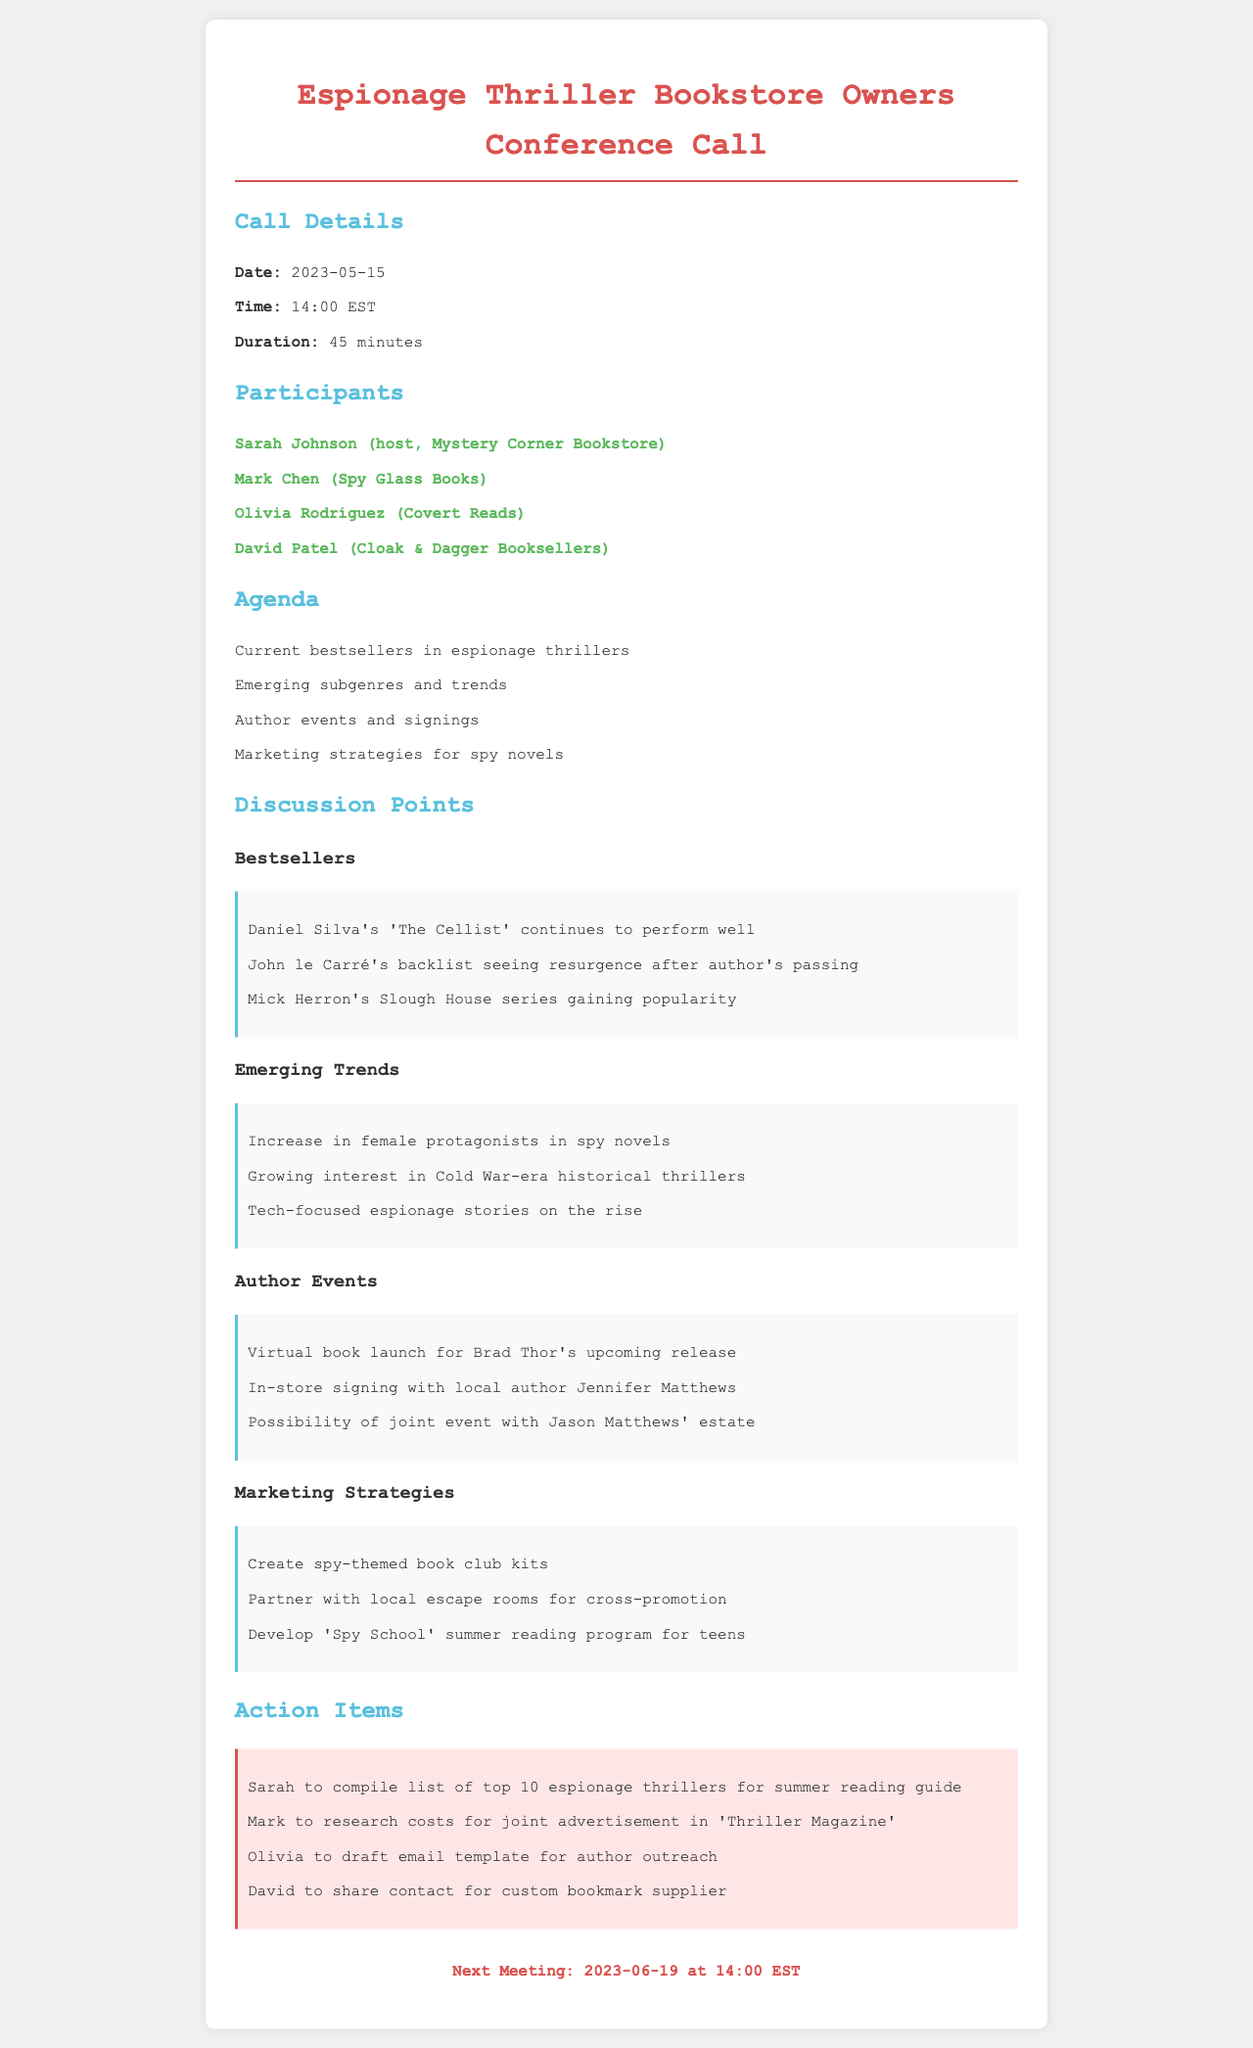what is the date of the conference call? The date of the conference call is specified under the Call Details section.
Answer: 2023-05-15 who is the host of the conference call? The host of the conference call is listed among the participants.
Answer: Sarah Johnson which book by Daniel Silva is mentioned as a bestseller? The document lists specific bestselling books under the Discussion Points section.
Answer: The Cellist how many participants were in the conference call? The number of participants can be counted from the Participants section.
Answer: 4 what is one emerging trend in espionage thrillers? Emerging trends are enumerated in the Discussion Points section, requiring reasoning to identify any one of them.
Answer: Increase in female protagonists what action item is assigned to Mark? Action items are outlined clearly in the Action Items section.
Answer: Research costs for joint advertisement in 'Thriller Magazine' when is the next meeting scheduled? The next meeting date is provided at the end of the document.
Answer: 2023-06-19 name one marketing strategy discussed. Marketing strategies are listed under the Discussion Points, requiring retrieval of specific information.
Answer: Create spy-themed book club kits 